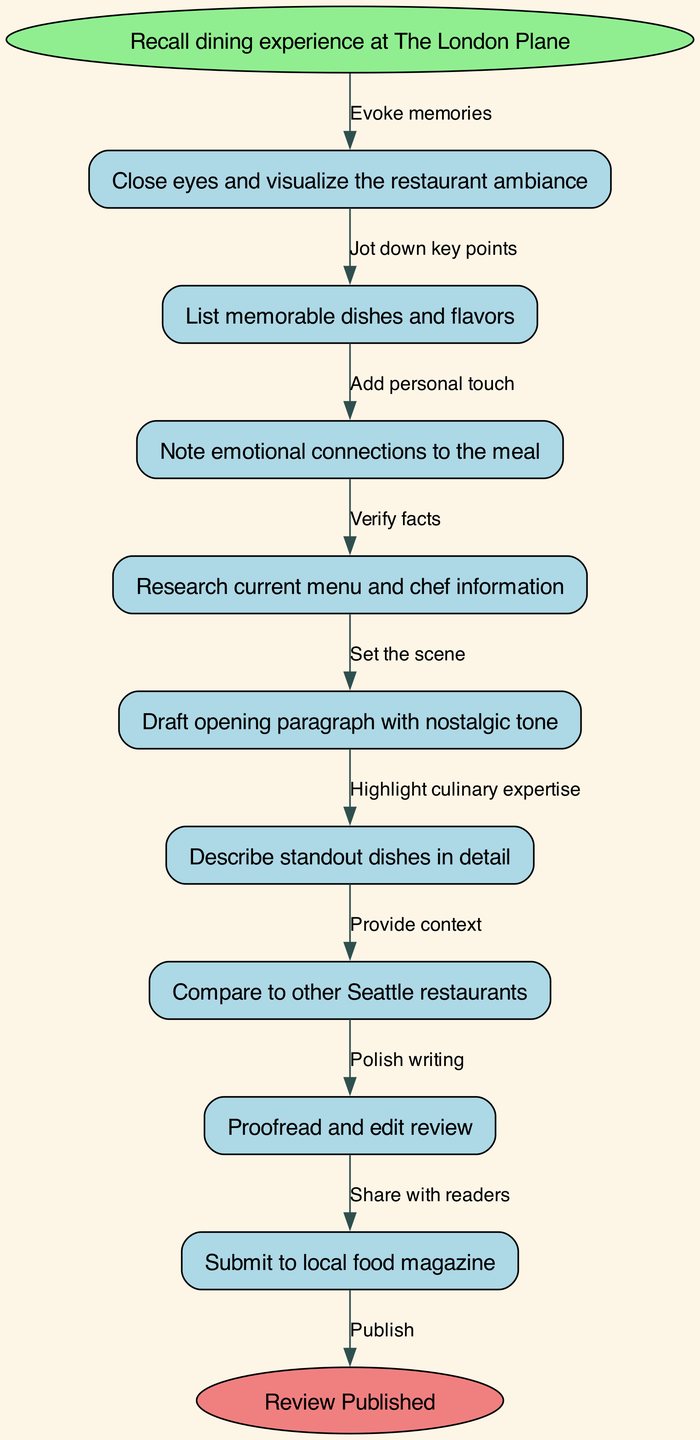What is the first step in the review process? The first node in the diagram is "Recall dining experience at The London Plane," indicating this is the initial action to undertake when beginning the review process.
Answer: Recall dining experience at The London Plane How many nodes are there in total? The diagram contains a start node, eight additional nodes, and an end node, amounting to ten nodes altogether.
Answer: Ten What emotional element is noted in the review process? The node "Note emotional connections to the meal" explicitly mentions the incorporation of personal emotions, which is essential in creating a nostalgic review.
Answer: Note emotional connections to the meal Which node follows "List memorable dishes and flavors"? According to the flow of the diagram, the node that follows "List memorable dishes and flavors" is "Note emotional connections to the meal," showing the progression from details about the food to the emotional context surrounding the meal.
Answer: Note emotional connections to the meal What is the final action taken before publication? The last action specified in the diagram prior to reaching the publishing state is "Submit to local food magazine," which indicates the completion of the review process.
Answer: Submit to local food magazine How does the node "Proofread and edit review" relate to the overall writing process? "Proofread and edit review" serves as a quality control step in the process, ensuring the clarity and correctness of the review before it proceeds to publication. This relationship highlights the importance of this step in the writing process.
Answer: Quality control step What step involves verifying factual information? The node "Research current menu and chef information" is crucial for verifying factual data about the restaurant, ensuring the review reflects accurate and up-to-date information.
Answer: Research current menu and chef information How many edges connect the nodes? There are nine edges in total connecting the various nodes together, representing the flow from one action to the next in the review writing process.
Answer: Nine edges What is the purpose of the "Draft opening paragraph with nostalgic tone" node? This node emphasizes setting the emotional tone of the review right from the beginning, engaging readers with a sense of nostalgia related to the dining experience.
Answer: Set emotional tone What distinguishes the start node from the end node? The start node indicates the beginning of the review writing process, while the end node, "Review Published," signifies the completion and sharing of the review with readers, marking a distinct start and finish in the flow diagram.
Answer: Start and finish distinction 